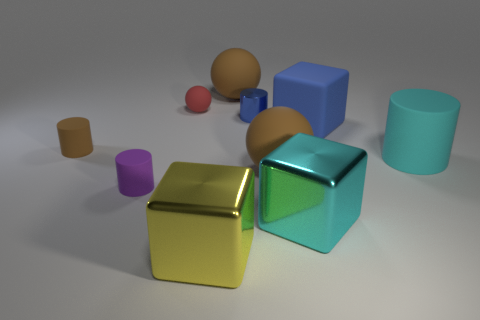Are there the same number of purple rubber things in front of the tiny purple rubber cylinder and cyan cylinders? After examining the image, it appears that the count of purple objects does not equal the count of cyan objects in the given view, although without a 360-degree perspective, we cannot be certain if this holds true from every angle. 